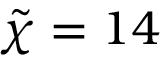<formula> <loc_0><loc_0><loc_500><loc_500>\tilde { \chi } = 1 4</formula> 